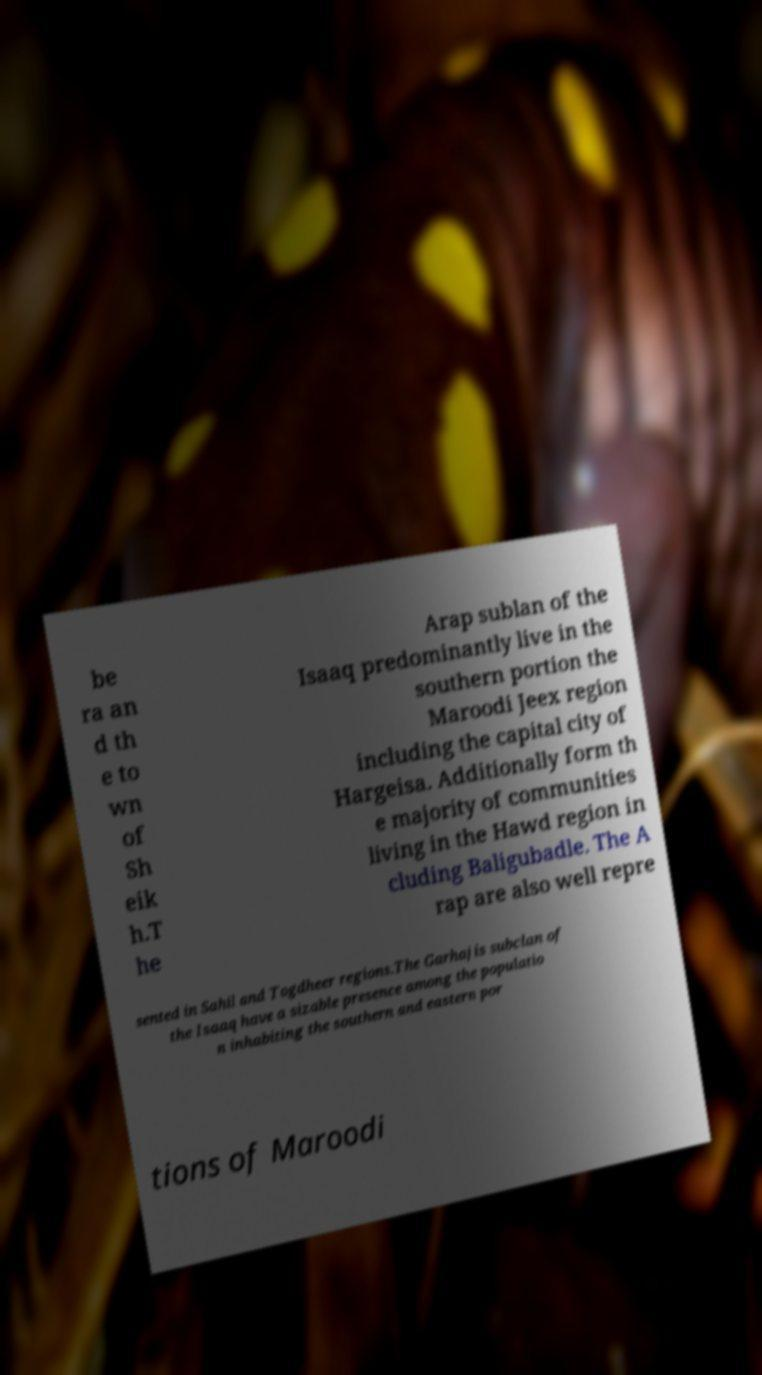What messages or text are displayed in this image? I need them in a readable, typed format. be ra an d th e to wn of Sh eik h.T he Arap sublan of the Isaaq predominantly live in the southern portion the Maroodi Jeex region including the capital city of Hargeisa. Additionally form th e majority of communities living in the Hawd region in cluding Baligubadle. The A rap are also well repre sented in Sahil and Togdheer regions.The Garhajis subclan of the Isaaq have a sizable presence among the populatio n inhabiting the southern and eastern por tions of Maroodi 